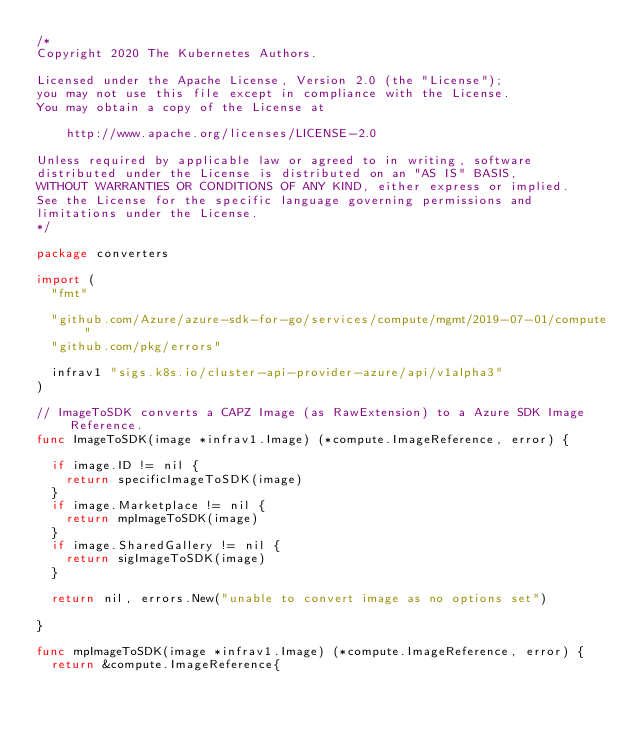<code> <loc_0><loc_0><loc_500><loc_500><_Go_>/*
Copyright 2020 The Kubernetes Authors.

Licensed under the Apache License, Version 2.0 (the "License");
you may not use this file except in compliance with the License.
You may obtain a copy of the License at

    http://www.apache.org/licenses/LICENSE-2.0

Unless required by applicable law or agreed to in writing, software
distributed under the License is distributed on an "AS IS" BASIS,
WITHOUT WARRANTIES OR CONDITIONS OF ANY KIND, either express or implied.
See the License for the specific language governing permissions and
limitations under the License.
*/

package converters

import (
	"fmt"

	"github.com/Azure/azure-sdk-for-go/services/compute/mgmt/2019-07-01/compute"
	"github.com/pkg/errors"

	infrav1 "sigs.k8s.io/cluster-api-provider-azure/api/v1alpha3"
)

// ImageToSDK converts a CAPZ Image (as RawExtension) to a Azure SDK Image Reference.
func ImageToSDK(image *infrav1.Image) (*compute.ImageReference, error) {

	if image.ID != nil {
		return specificImageToSDK(image)
	}
	if image.Marketplace != nil {
		return mpImageToSDK(image)
	}
	if image.SharedGallery != nil {
		return sigImageToSDK(image)
	}

	return nil, errors.New("unable to convert image as no options set")

}

func mpImageToSDK(image *infrav1.Image) (*compute.ImageReference, error) {
	return &compute.ImageReference{</code> 